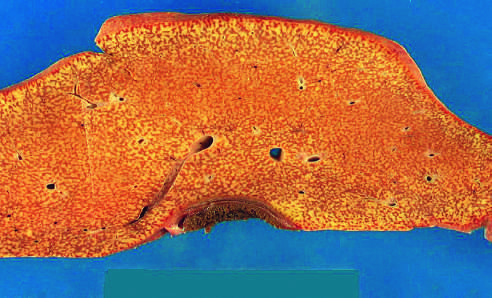s endoscopy small (700 g), bile-stained, soft, and congested?
Answer the question using a single word or phrase. No 